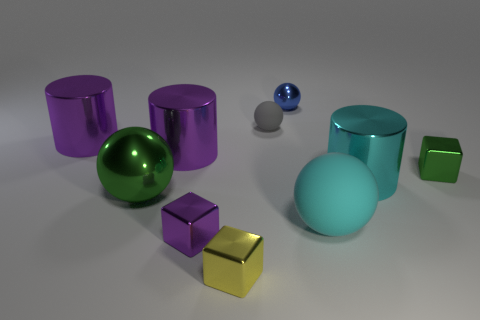The tiny object that is right of the matte ball to the right of the small matte thing is what color?
Your answer should be very brief. Green. Are there any other spheres of the same color as the big shiny ball?
Offer a very short reply. No. There is a matte ball behind the small block that is behind the shiny cylinder to the right of the yellow object; how big is it?
Provide a succinct answer. Small. There is a tiny green thing; is its shape the same as the large shiny thing that is to the right of the small blue metal sphere?
Provide a succinct answer. No. How many other things are there of the same size as the blue object?
Make the answer very short. 4. There is a green metallic thing to the right of the small matte sphere; what size is it?
Provide a short and direct response. Small. How many green objects have the same material as the green block?
Your answer should be very brief. 1. There is a cyan object that is behind the big rubber ball; does it have the same shape as the big cyan matte thing?
Your response must be concise. No. There is a tiny shiny thing to the right of the blue object; what is its shape?
Provide a short and direct response. Cube. What size is the metallic cylinder that is the same color as the large matte ball?
Your answer should be very brief. Large. 